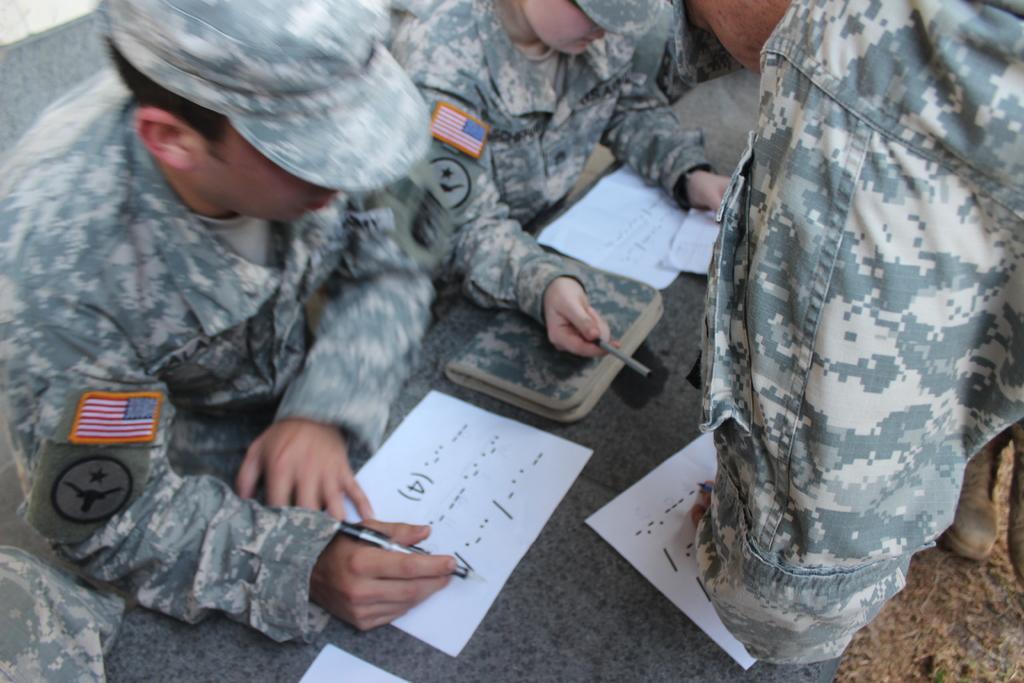Could you give a brief overview of what you see in this image? In this image we can see many persons around the table. On the table we can see papers and books. 